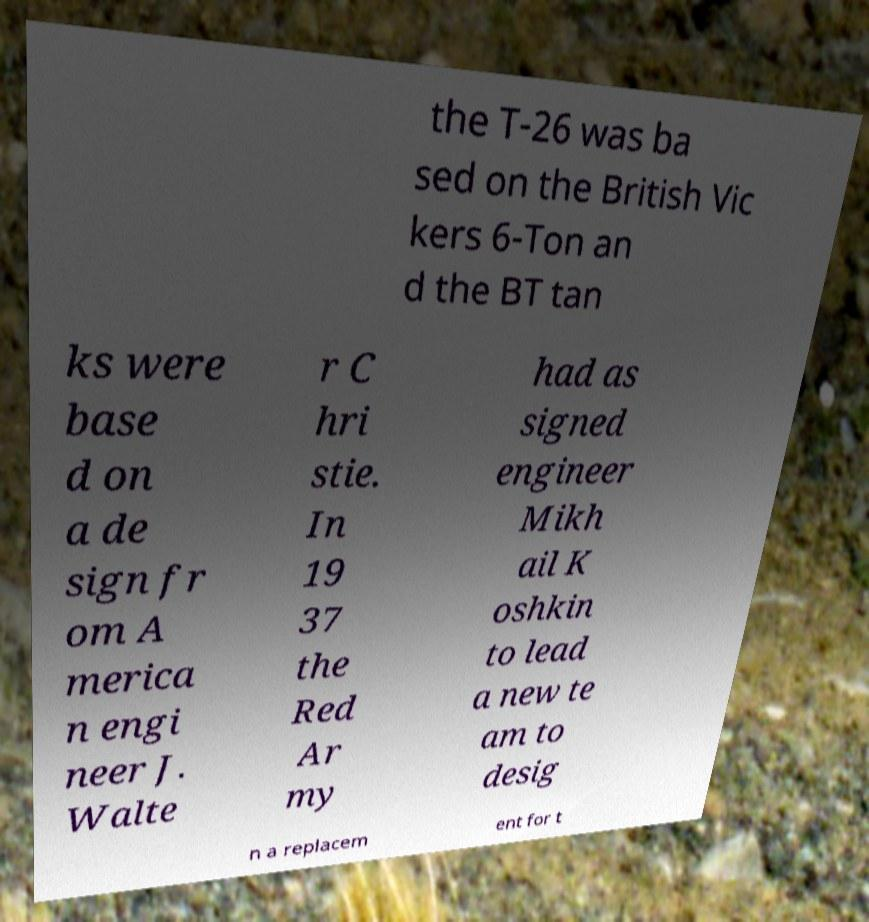Please read and relay the text visible in this image. What does it say? the T-26 was ba sed on the British Vic kers 6-Ton an d the BT tan ks were base d on a de sign fr om A merica n engi neer J. Walte r C hri stie. In 19 37 the Red Ar my had as signed engineer Mikh ail K oshkin to lead a new te am to desig n a replacem ent for t 